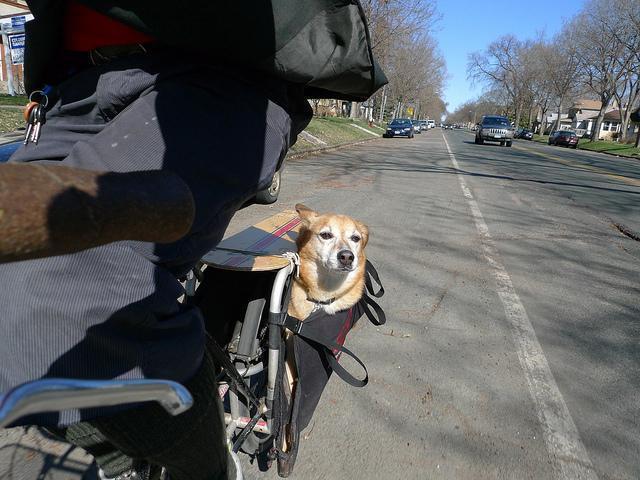How is the dog probably traveling?
Make your selection from the four choices given to correctly answer the question.
Options: Motorcycle, bike, scooter, skateboard. Bike. 